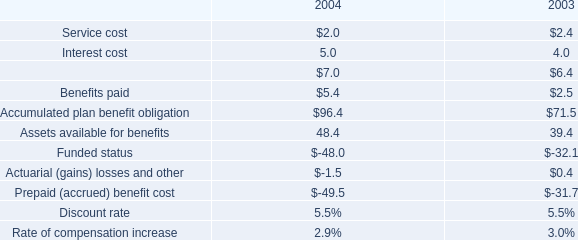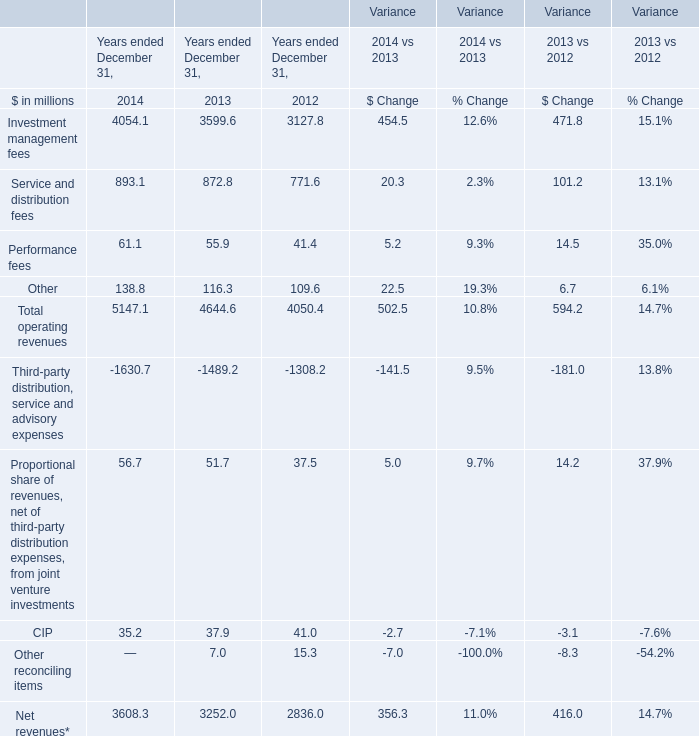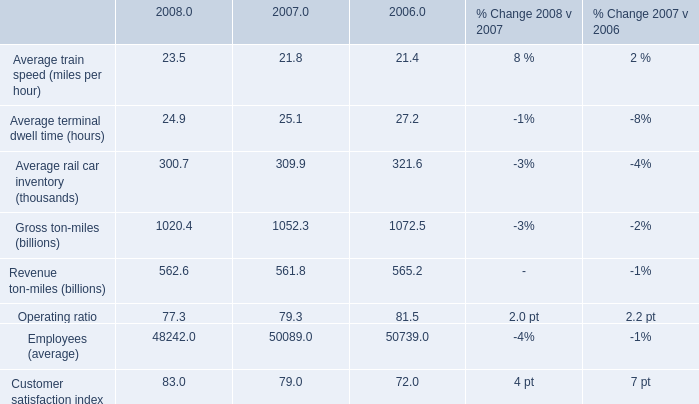What's the growth rate of Total operating revenues in 2013? 
Computations: ((4644.6 - 4050.4) / 4050.4)
Answer: 0.1467. 